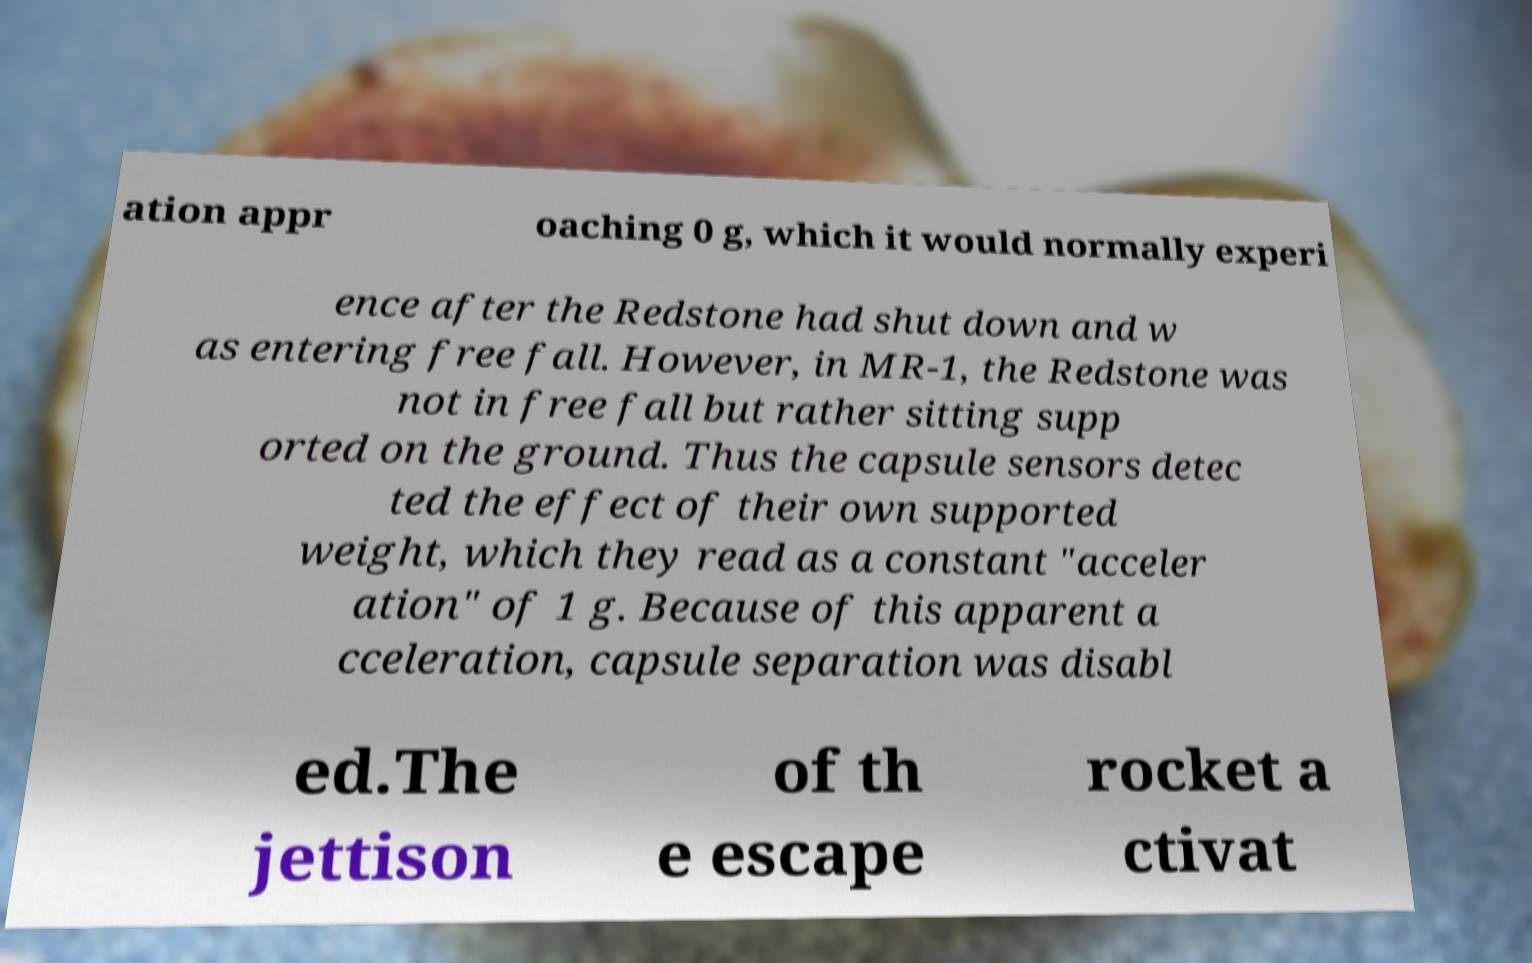Can you read and provide the text displayed in the image?This photo seems to have some interesting text. Can you extract and type it out for me? ation appr oaching 0 g, which it would normally experi ence after the Redstone had shut down and w as entering free fall. However, in MR-1, the Redstone was not in free fall but rather sitting supp orted on the ground. Thus the capsule sensors detec ted the effect of their own supported weight, which they read as a constant "acceler ation" of 1 g. Because of this apparent a cceleration, capsule separation was disabl ed.The jettison of th e escape rocket a ctivat 